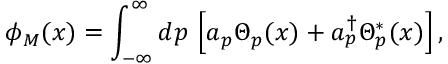<formula> <loc_0><loc_0><loc_500><loc_500>\phi _ { M } ( x ) = \int _ { - \infty } ^ { \infty } d p \, \left [ a _ { p } \Theta _ { p } ( x ) + a _ { p } ^ { \dag } \Theta _ { p } ^ { * } ( x ) \right ] ,</formula> 